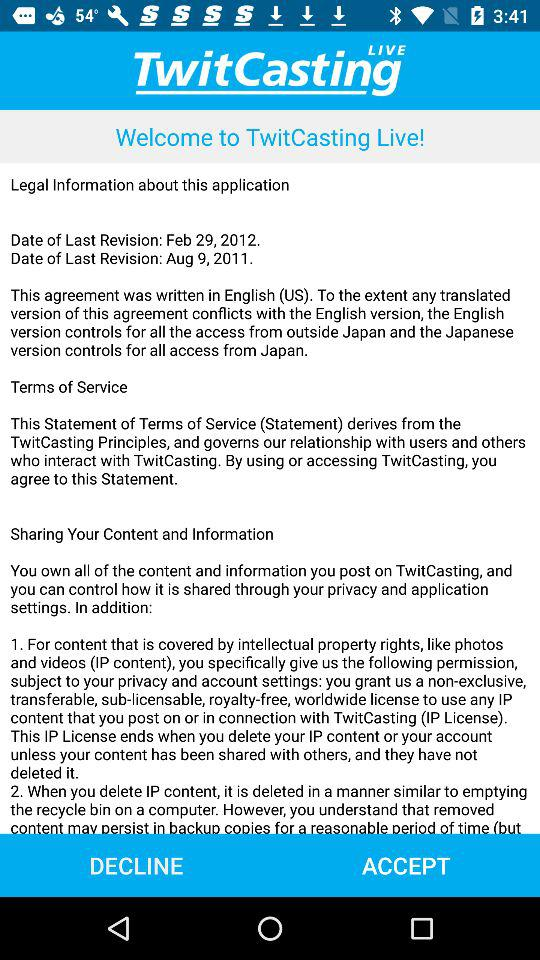What is the name of the application? The name of the application is "TwitCasting Live". 